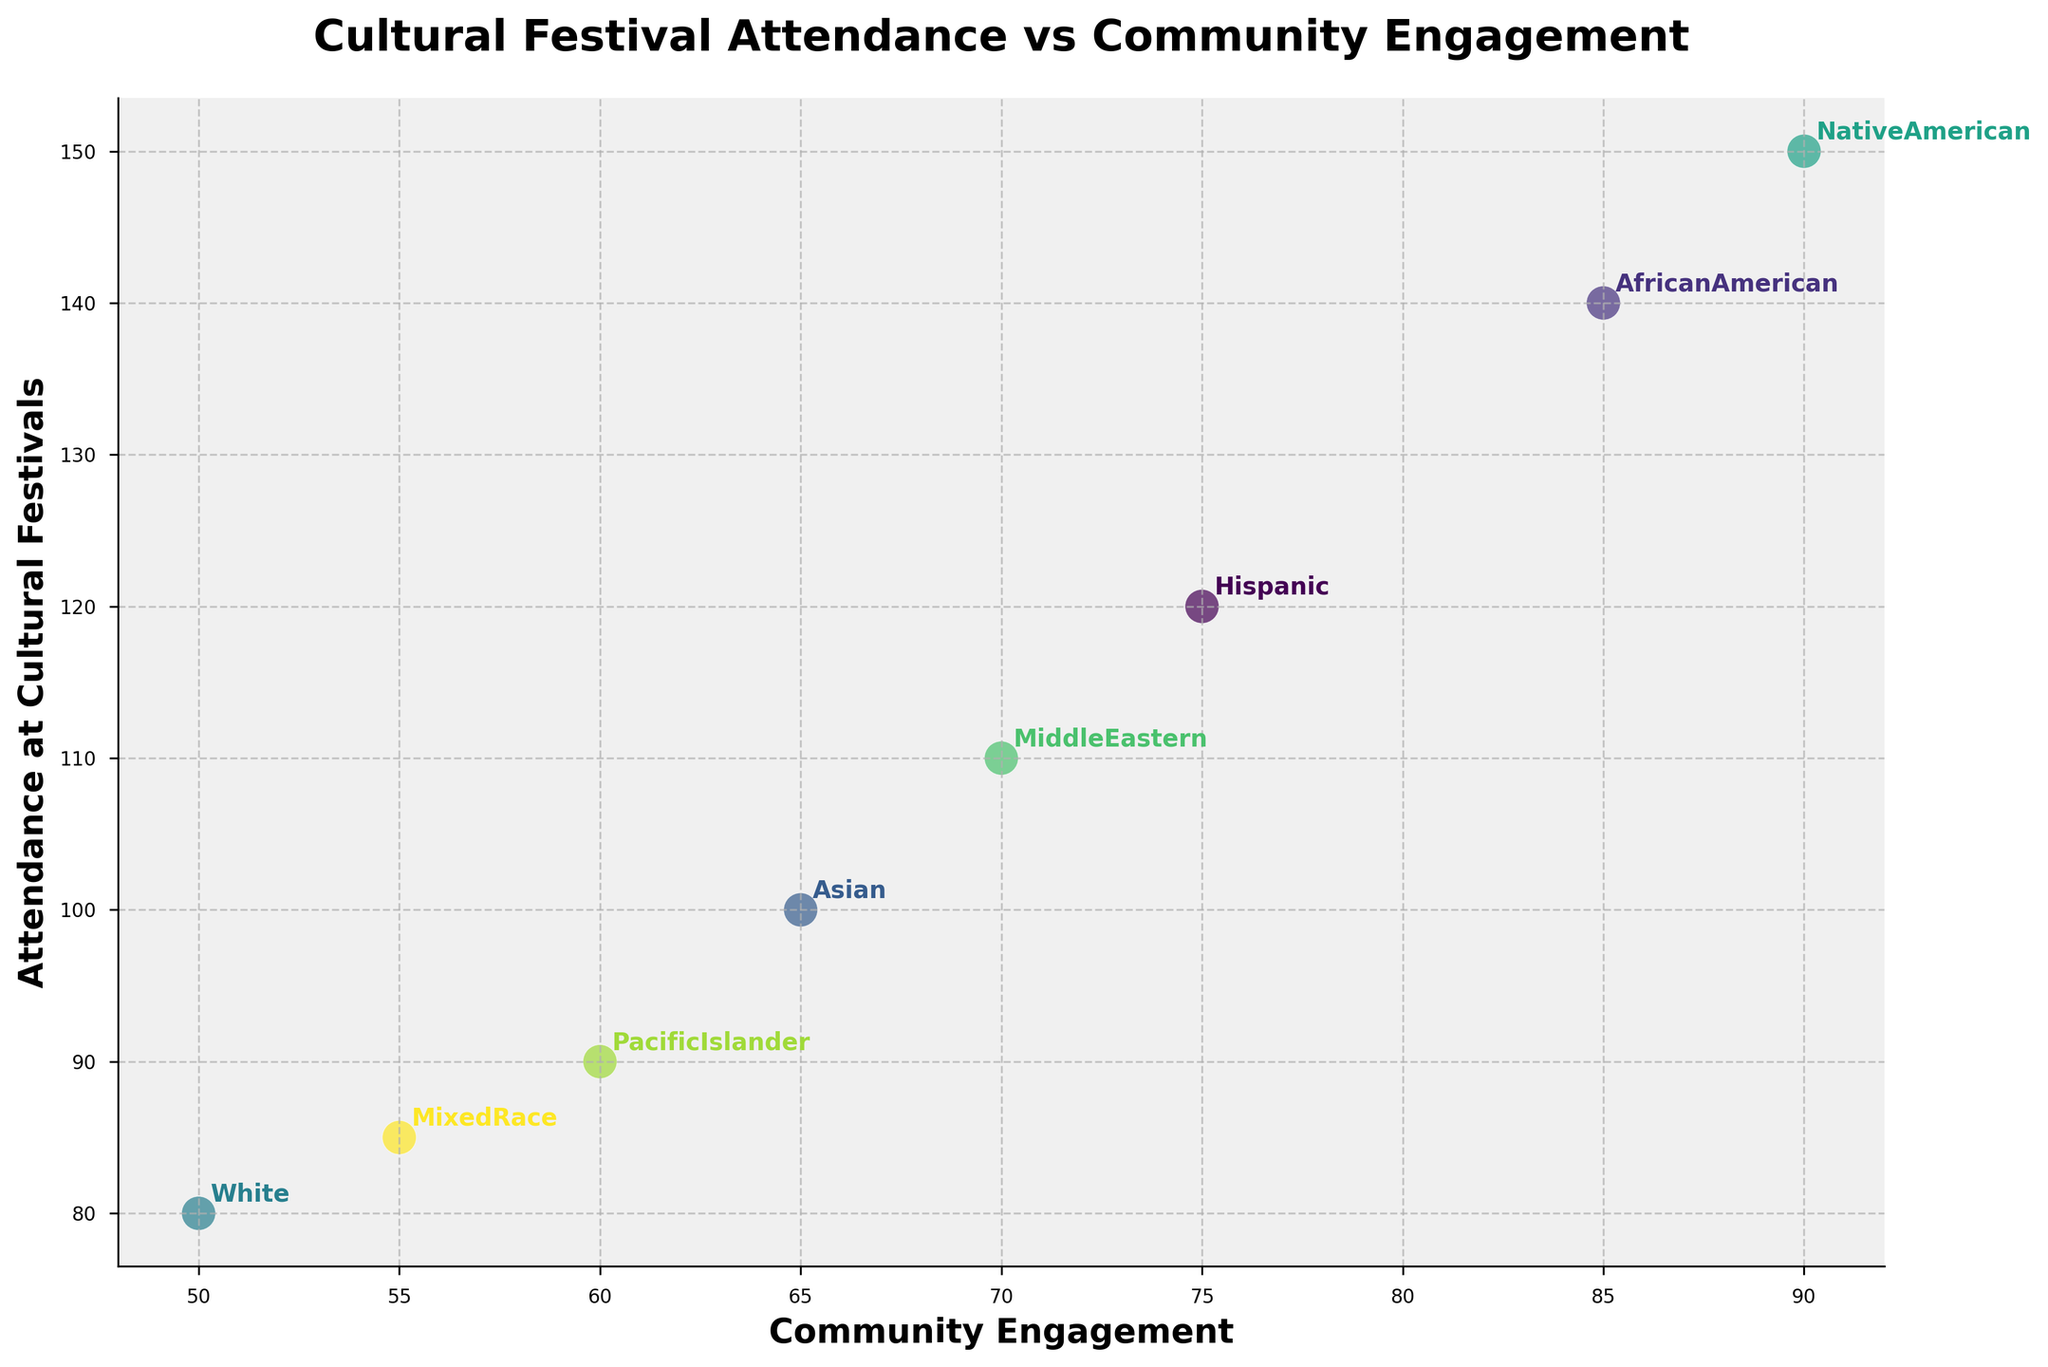What is the title of the scatter plot? The title of the scatter plot is prominently displayed at the top of the figure.
Answer: Cultural Festival Attendance vs Community Engagement How many ethnic groups are represented in the scatter plot? Each point in the scatter plot corresponds to a different ethnic group and their respective label is annotated next to the points. Count the number of unique labels.
Answer: 8 Which ethnic group has the highest community engagement? Look for the point that is farthest to the right on the x-axis, then check its annotation.
Answer: Native American Which ethnic group has the lowest attendance at cultural festivals? Look for the point that is at the bottom of the y-axis, then check its annotation.
Answer: White How many data points are between 50 and 80 in community engagement? Identify the data points whose x-values fall between 50 and 80. Count these points.
Answer: 2 What is the difference in attendance at cultural festivals between the African American and Hispanic groups? Check the y-values for both African American (140) and Hispanic (120). Subtract the value of Hispanic from African American.
Answer: 20 Which ethnic group has higher attendance at cultural festivals compared to the Asian group? Compare the y-value of the Asian group (100) with the y-values of other groups. Identify the groups with higher y-values.
Answer: Hispanic, African American, Native American, Middle Eastern What is the average attendance at cultural festivals for the White and Mixed Race ethnic groups? Find the y-values for White (80) and Mixed Race (85). Sum these values and divide by the number of groups (2).
Answer: (80 + 85) / 2 = 82.5 Is there a positive correlation between community engagement and attendance at cultural festivals? Observe the overall trend of the data points. If the points generally increase in y-value as the x-value increases, then there is a positive correlation.
Answer: Yes Which ethnic group appears to be the most balanced between community engagement and attendance at cultural festivals? Look for the point that falls near the middle of both axes, indicating a balance. Compare Community Engagement and Attendance to find the most balanced.
Answer: Middle Eastern 